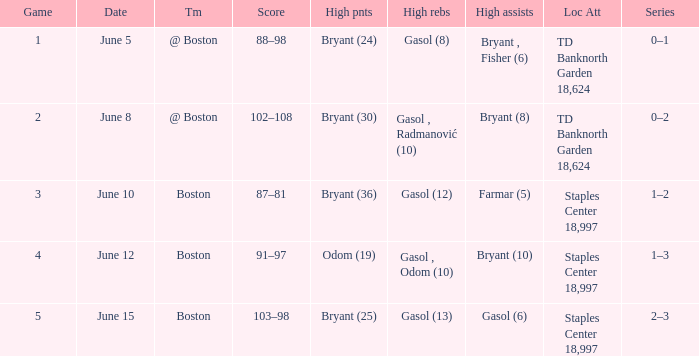Name the series on june 5 0–1. 